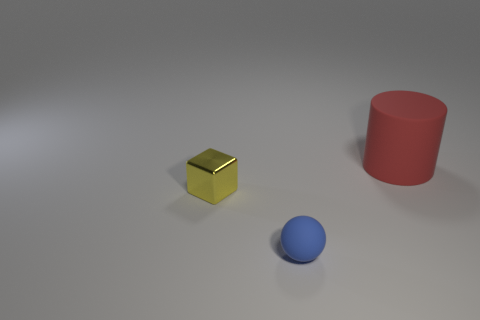Add 3 big yellow matte blocks. How many objects exist? 6 Subtract all balls. How many objects are left? 2 Add 1 small yellow metallic cylinders. How many small yellow metallic cylinders exist? 1 Subtract 0 red cubes. How many objects are left? 3 Subtract all red matte cylinders. Subtract all big red matte things. How many objects are left? 1 Add 2 big red matte things. How many big red matte things are left? 3 